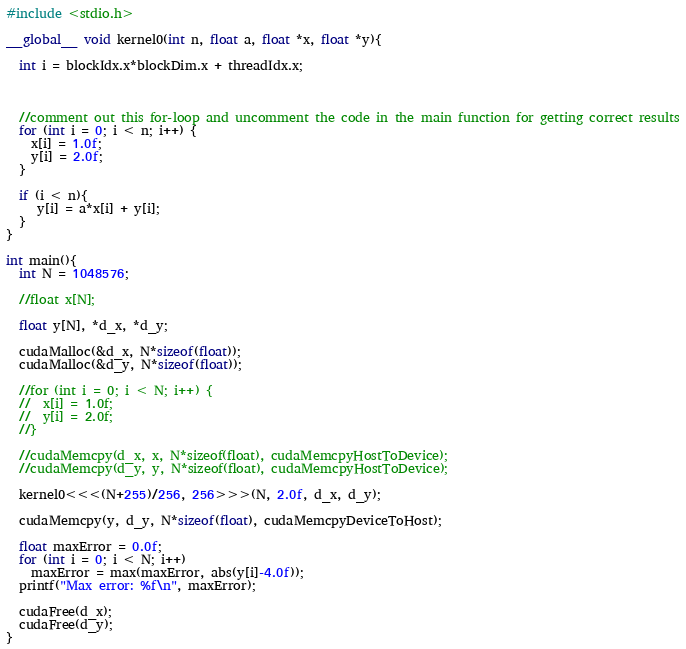Convert code to text. <code><loc_0><loc_0><loc_500><loc_500><_Cuda_>#include <stdio.h>

__global__ void kernel0(int n, float a, float *x, float *y){

  int i = blockIdx.x*blockDim.x + threadIdx.x;
 


  //comment out this for-loop and uncomment the code in the main function for getting correct results
  for (int i = 0; i < n; i++) {
    x[i] = 1.0f;
    y[i] = 2.0f;
  }

  if (i < n){
	 y[i] = a*x[i] + y[i];
  }
}

int main(){
  int N = 1048576;

  //float x[N];

  float y[N], *d_x, *d_y;

  cudaMalloc(&d_x, N*sizeof(float)); 
  cudaMalloc(&d_y, N*sizeof(float));

  //for (int i = 0; i < N; i++) {
  //  x[i] = 1.0f;
  //  y[i] = 2.0f;
  //}

  //cudaMemcpy(d_x, x, N*sizeof(float), cudaMemcpyHostToDevice);
  //cudaMemcpy(d_y, y, N*sizeof(float), cudaMemcpyHostToDevice);

  kernel0<<<(N+255)/256, 256>>>(N, 2.0f, d_x, d_y);

  cudaMemcpy(y, d_y, N*sizeof(float), cudaMemcpyDeviceToHost);

  float maxError = 0.0f;
  for (int i = 0; i < N; i++)
    maxError = max(maxError, abs(y[i]-4.0f));
  printf("Max error: %f\n", maxError);

  cudaFree(d_x);
  cudaFree(d_y);
}
</code> 